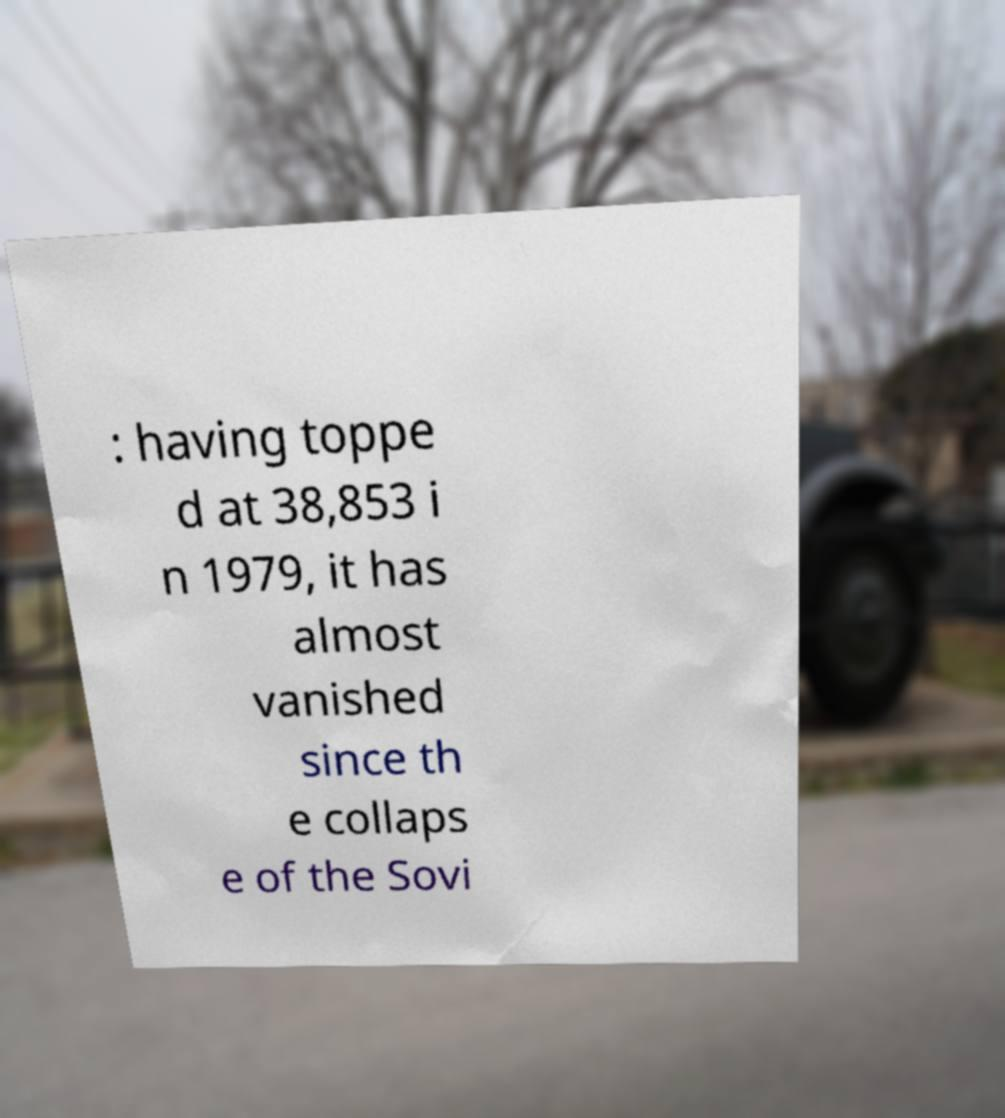Please identify and transcribe the text found in this image. : having toppe d at 38,853 i n 1979, it has almost vanished since th e collaps e of the Sovi 